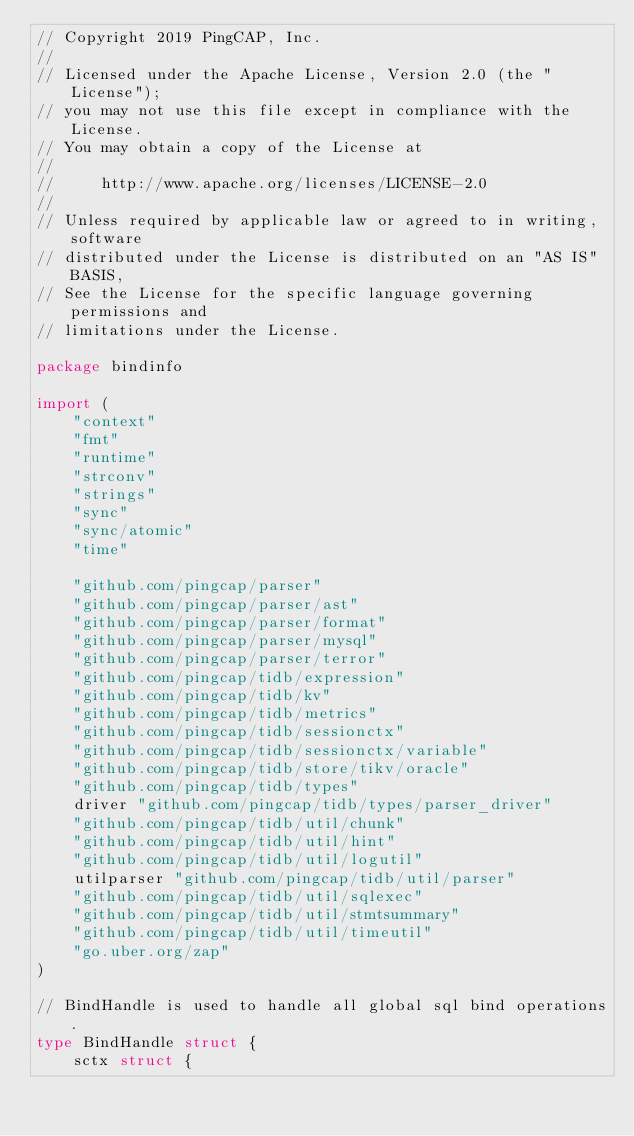Convert code to text. <code><loc_0><loc_0><loc_500><loc_500><_Go_>// Copyright 2019 PingCAP, Inc.
//
// Licensed under the Apache License, Version 2.0 (the "License");
// you may not use this file except in compliance with the License.
// You may obtain a copy of the License at
//
//     http://www.apache.org/licenses/LICENSE-2.0
//
// Unless required by applicable law or agreed to in writing, software
// distributed under the License is distributed on an "AS IS" BASIS,
// See the License for the specific language governing permissions and
// limitations under the License.

package bindinfo

import (
	"context"
	"fmt"
	"runtime"
	"strconv"
	"strings"
	"sync"
	"sync/atomic"
	"time"

	"github.com/pingcap/parser"
	"github.com/pingcap/parser/ast"
	"github.com/pingcap/parser/format"
	"github.com/pingcap/parser/mysql"
	"github.com/pingcap/parser/terror"
	"github.com/pingcap/tidb/expression"
	"github.com/pingcap/tidb/kv"
	"github.com/pingcap/tidb/metrics"
	"github.com/pingcap/tidb/sessionctx"
	"github.com/pingcap/tidb/sessionctx/variable"
	"github.com/pingcap/tidb/store/tikv/oracle"
	"github.com/pingcap/tidb/types"
	driver "github.com/pingcap/tidb/types/parser_driver"
	"github.com/pingcap/tidb/util/chunk"
	"github.com/pingcap/tidb/util/hint"
	"github.com/pingcap/tidb/util/logutil"
	utilparser "github.com/pingcap/tidb/util/parser"
	"github.com/pingcap/tidb/util/sqlexec"
	"github.com/pingcap/tidb/util/stmtsummary"
	"github.com/pingcap/tidb/util/timeutil"
	"go.uber.org/zap"
)

// BindHandle is used to handle all global sql bind operations.
type BindHandle struct {
	sctx struct {</code> 